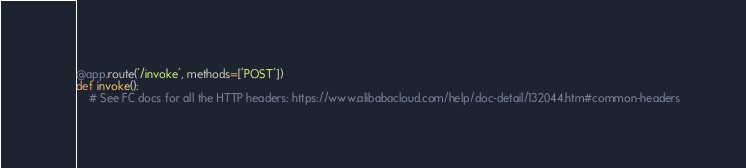<code> <loc_0><loc_0><loc_500><loc_500><_Python_>
@app.route('/invoke', methods=['POST'])
def invoke():
    # See FC docs for all the HTTP headers: https://www.alibabacloud.com/help/doc-detail/132044.htm#common-headers</code> 